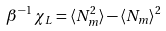Convert formula to latex. <formula><loc_0><loc_0><loc_500><loc_500>\beta ^ { - 1 } \, \chi _ { L } = \langle N _ { m } ^ { 2 } \rangle - \langle N _ { m } \rangle ^ { 2 }</formula> 